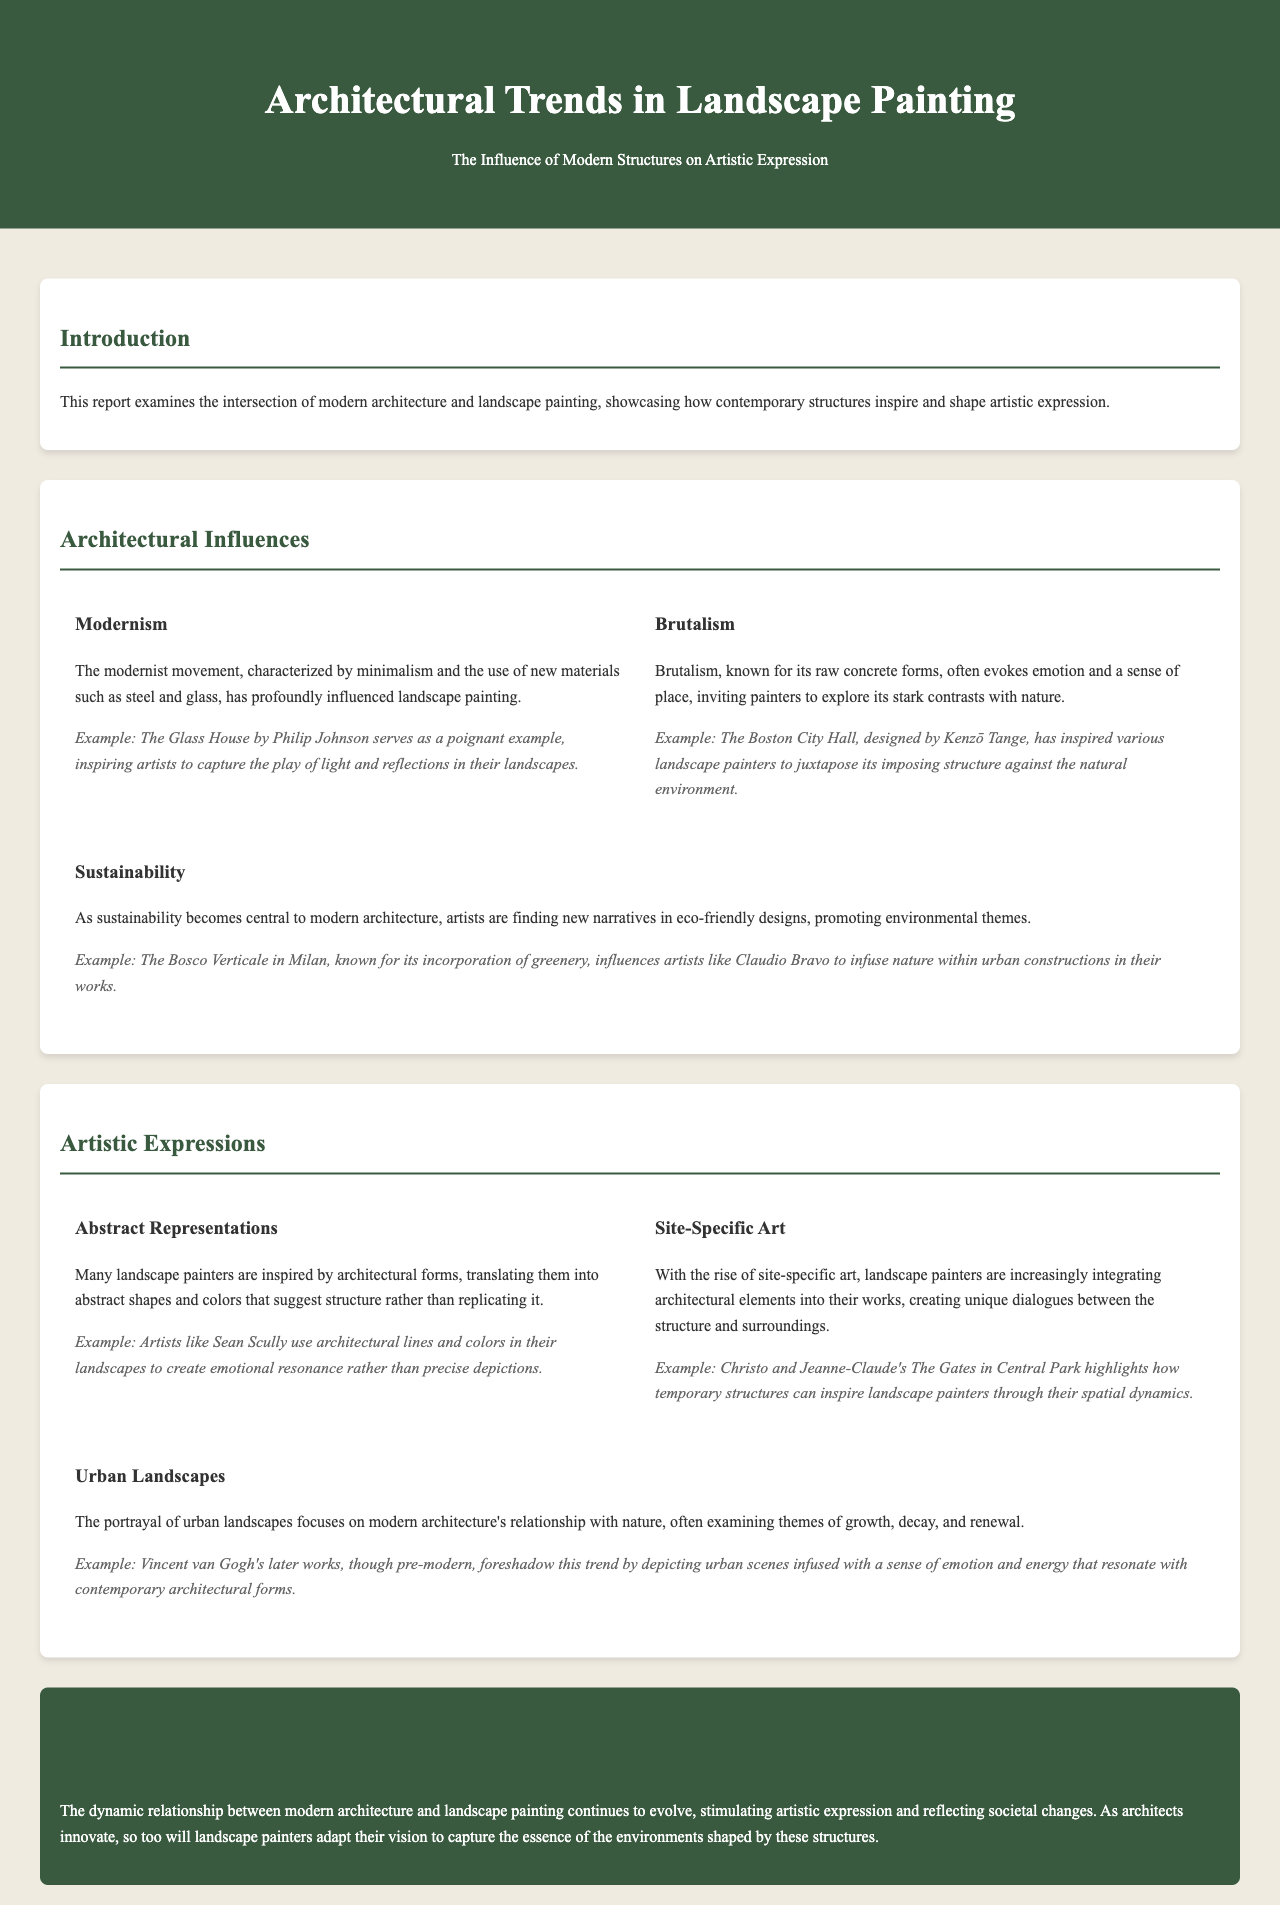What modern architectural movement is mentioned first? The first architectural movement mentioned is Modernism, characterized by minimalism and the use of new materials.
Answer: Modernism Who designed The Glass House? The Glass House is associated with architect Philip Johnson, as mentioned in the example.
Answer: Philip Johnson Which architectural style is known for its raw concrete forms? The architectural style recognized for its raw concrete forms is Brutalism.
Answer: Brutalism What is the key theme associated with sustainability in architecture? The theme associated with sustainability in architecture is the promotion of environmental narratives in artistic works.
Answer: Environmental themes Name an artist inspired by the Bosco Verticale. The document mentions Claudio Bravo as an artist inspired by the Bosco Verticale in Milan.
Answer: Claudio Bravo Which artist is known for using abstract representations of architectural forms? Sean Scully is identified as an artist utilizing abstract representations of architectural forms in landscape art.
Answer: Sean Scully What type of art are landscape painters increasingly integrating into their works? Landscape painters are integrating site-specific art, creating interactions between structures and their surroundings.
Answer: Site-specific art In what context is Christo and Jeanne-Claude's The Gates mentioned? It is mentioned as an example of how temporary structures can inspire landscape painters through their spatial dynamics.
Answer: Spatial dynamics What aspect of urban landscapes does the document emphasize? The document emphasizes the relationship between modern architecture and nature in urban landscapes.
Answer: Relationship with nature 